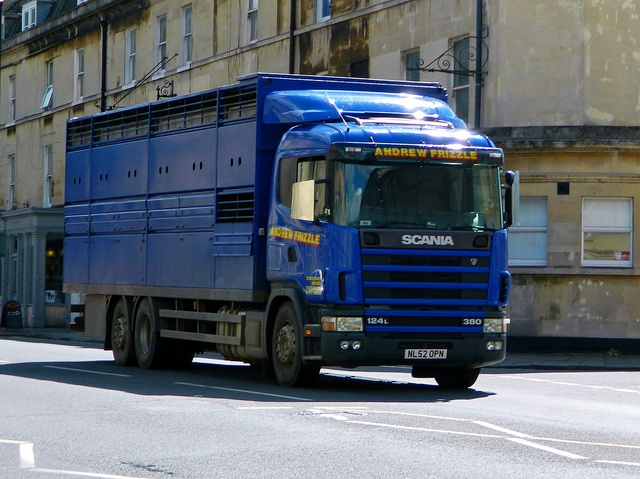Describe the objects in this image and their specific colors. I can see a truck in white, black, navy, darkblue, and gray tones in this image. 